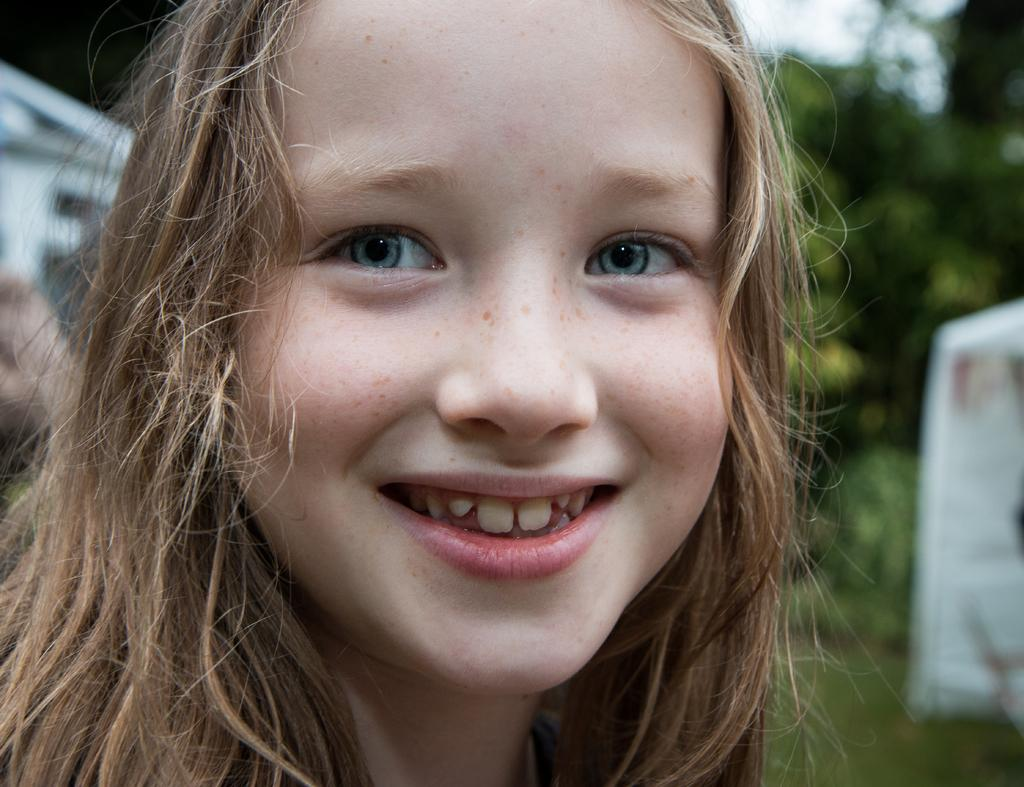Who is in the picture? There is a girl in the picture. What is the girl doing in the picture? The girl is smiling in the picture. What is the color of the girl's hair? The girl has brown hair. What can be seen in the background of the picture? There are trees in the background of the picture. How is the background of the picture depicted? The background is blurred in the picture. What type of destruction can be seen in the image? There is no destruction present in the image; it features a smiling girl with brown hair in front of trees. How many wings can be seen on the girl in the image? The girl does not have any wings in the image; she is a human with two arms. 